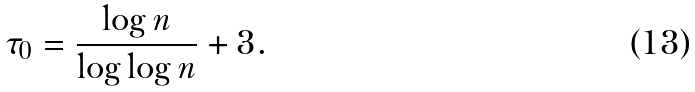Convert formula to latex. <formula><loc_0><loc_0><loc_500><loc_500>\tau _ { 0 } = \frac { \log n } { \log \log n } + 3 .</formula> 